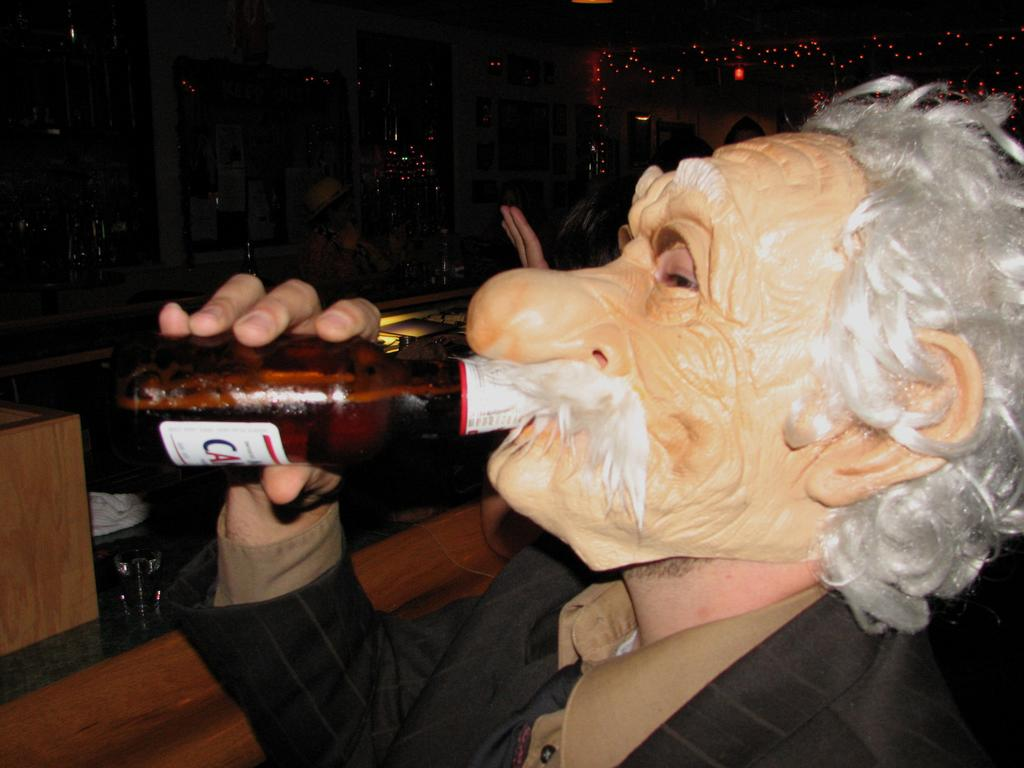What is the main subject of the image? There is a man in the image. What is the man wearing on his face? The man is wearing a face mask. What activity is the man engaged in? The man is drinking a beer. What type of existence does the beam have in the image? There is no beam present in the image. What kind of beast can be seen interacting with the man in the image? There is no beast present in the image; the man is alone in the image. 